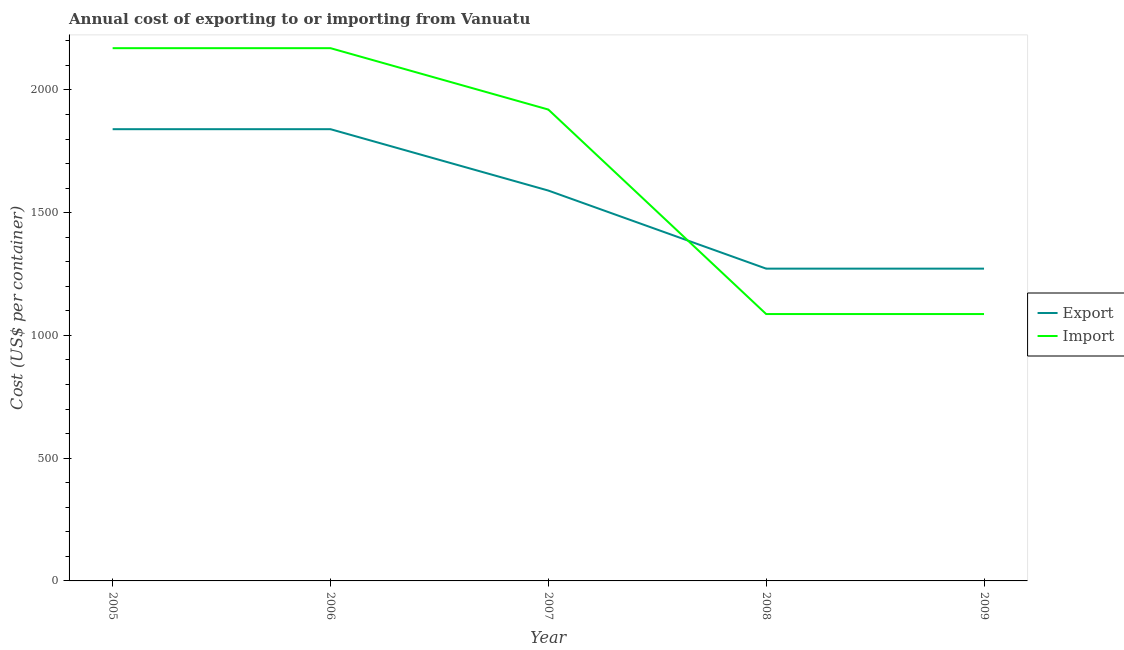Does the line corresponding to export cost intersect with the line corresponding to import cost?
Keep it short and to the point. Yes. Is the number of lines equal to the number of legend labels?
Give a very brief answer. Yes. What is the export cost in 2008?
Your response must be concise. 1272. Across all years, what is the maximum import cost?
Your response must be concise. 2170. Across all years, what is the minimum import cost?
Offer a terse response. 1087. In which year was the export cost minimum?
Give a very brief answer. 2008. What is the total export cost in the graph?
Your answer should be very brief. 7814. What is the difference between the export cost in 2005 and that in 2009?
Give a very brief answer. 568. What is the difference between the export cost in 2007 and the import cost in 2006?
Offer a very short reply. -580. What is the average export cost per year?
Make the answer very short. 1562.8. In the year 2009, what is the difference between the import cost and export cost?
Make the answer very short. -185. In how many years, is the import cost greater than 1000 US$?
Your response must be concise. 5. What is the ratio of the export cost in 2006 to that in 2008?
Offer a very short reply. 1.45. Is the export cost in 2007 less than that in 2009?
Your answer should be compact. No. Is the difference between the export cost in 2007 and 2009 greater than the difference between the import cost in 2007 and 2009?
Provide a succinct answer. No. What is the difference between the highest and the second highest export cost?
Your answer should be very brief. 0. What is the difference between the highest and the lowest export cost?
Offer a terse response. 568. In how many years, is the export cost greater than the average export cost taken over all years?
Provide a short and direct response. 3. Does the import cost monotonically increase over the years?
Ensure brevity in your answer.  No. Is the import cost strictly greater than the export cost over the years?
Your answer should be very brief. No. Is the export cost strictly less than the import cost over the years?
Your answer should be compact. No. How many years are there in the graph?
Offer a very short reply. 5. Does the graph contain any zero values?
Give a very brief answer. No. How are the legend labels stacked?
Your answer should be very brief. Vertical. What is the title of the graph?
Offer a terse response. Annual cost of exporting to or importing from Vanuatu. What is the label or title of the X-axis?
Make the answer very short. Year. What is the label or title of the Y-axis?
Give a very brief answer. Cost (US$ per container). What is the Cost (US$ per container) in Export in 2005?
Your answer should be compact. 1840. What is the Cost (US$ per container) of Import in 2005?
Give a very brief answer. 2170. What is the Cost (US$ per container) in Export in 2006?
Give a very brief answer. 1840. What is the Cost (US$ per container) in Import in 2006?
Provide a short and direct response. 2170. What is the Cost (US$ per container) in Export in 2007?
Offer a terse response. 1590. What is the Cost (US$ per container) of Import in 2007?
Ensure brevity in your answer.  1920. What is the Cost (US$ per container) of Export in 2008?
Make the answer very short. 1272. What is the Cost (US$ per container) of Import in 2008?
Your answer should be very brief. 1087. What is the Cost (US$ per container) in Export in 2009?
Your response must be concise. 1272. What is the Cost (US$ per container) in Import in 2009?
Keep it short and to the point. 1087. Across all years, what is the maximum Cost (US$ per container) in Export?
Provide a short and direct response. 1840. Across all years, what is the maximum Cost (US$ per container) of Import?
Your answer should be compact. 2170. Across all years, what is the minimum Cost (US$ per container) of Export?
Offer a terse response. 1272. Across all years, what is the minimum Cost (US$ per container) in Import?
Your answer should be very brief. 1087. What is the total Cost (US$ per container) of Export in the graph?
Give a very brief answer. 7814. What is the total Cost (US$ per container) in Import in the graph?
Give a very brief answer. 8434. What is the difference between the Cost (US$ per container) of Import in 2005 and that in 2006?
Your response must be concise. 0. What is the difference between the Cost (US$ per container) of Export in 2005 and that in 2007?
Ensure brevity in your answer.  250. What is the difference between the Cost (US$ per container) of Import in 2005 and that in 2007?
Provide a short and direct response. 250. What is the difference between the Cost (US$ per container) of Export in 2005 and that in 2008?
Provide a short and direct response. 568. What is the difference between the Cost (US$ per container) in Import in 2005 and that in 2008?
Provide a succinct answer. 1083. What is the difference between the Cost (US$ per container) of Export in 2005 and that in 2009?
Make the answer very short. 568. What is the difference between the Cost (US$ per container) in Import in 2005 and that in 2009?
Make the answer very short. 1083. What is the difference between the Cost (US$ per container) of Export in 2006 and that in 2007?
Your response must be concise. 250. What is the difference between the Cost (US$ per container) in Import in 2006 and that in 2007?
Your answer should be compact. 250. What is the difference between the Cost (US$ per container) of Export in 2006 and that in 2008?
Make the answer very short. 568. What is the difference between the Cost (US$ per container) in Import in 2006 and that in 2008?
Offer a very short reply. 1083. What is the difference between the Cost (US$ per container) in Export in 2006 and that in 2009?
Offer a terse response. 568. What is the difference between the Cost (US$ per container) in Import in 2006 and that in 2009?
Offer a very short reply. 1083. What is the difference between the Cost (US$ per container) in Export in 2007 and that in 2008?
Provide a succinct answer. 318. What is the difference between the Cost (US$ per container) of Import in 2007 and that in 2008?
Your answer should be very brief. 833. What is the difference between the Cost (US$ per container) in Export in 2007 and that in 2009?
Offer a terse response. 318. What is the difference between the Cost (US$ per container) of Import in 2007 and that in 2009?
Offer a very short reply. 833. What is the difference between the Cost (US$ per container) in Export in 2008 and that in 2009?
Provide a short and direct response. 0. What is the difference between the Cost (US$ per container) in Export in 2005 and the Cost (US$ per container) in Import in 2006?
Provide a succinct answer. -330. What is the difference between the Cost (US$ per container) in Export in 2005 and the Cost (US$ per container) in Import in 2007?
Your answer should be compact. -80. What is the difference between the Cost (US$ per container) in Export in 2005 and the Cost (US$ per container) in Import in 2008?
Give a very brief answer. 753. What is the difference between the Cost (US$ per container) of Export in 2005 and the Cost (US$ per container) of Import in 2009?
Offer a very short reply. 753. What is the difference between the Cost (US$ per container) of Export in 2006 and the Cost (US$ per container) of Import in 2007?
Provide a succinct answer. -80. What is the difference between the Cost (US$ per container) in Export in 2006 and the Cost (US$ per container) in Import in 2008?
Your answer should be compact. 753. What is the difference between the Cost (US$ per container) of Export in 2006 and the Cost (US$ per container) of Import in 2009?
Your answer should be compact. 753. What is the difference between the Cost (US$ per container) of Export in 2007 and the Cost (US$ per container) of Import in 2008?
Ensure brevity in your answer.  503. What is the difference between the Cost (US$ per container) of Export in 2007 and the Cost (US$ per container) of Import in 2009?
Your response must be concise. 503. What is the difference between the Cost (US$ per container) of Export in 2008 and the Cost (US$ per container) of Import in 2009?
Provide a succinct answer. 185. What is the average Cost (US$ per container) in Export per year?
Ensure brevity in your answer.  1562.8. What is the average Cost (US$ per container) in Import per year?
Ensure brevity in your answer.  1686.8. In the year 2005, what is the difference between the Cost (US$ per container) of Export and Cost (US$ per container) of Import?
Give a very brief answer. -330. In the year 2006, what is the difference between the Cost (US$ per container) in Export and Cost (US$ per container) in Import?
Offer a very short reply. -330. In the year 2007, what is the difference between the Cost (US$ per container) of Export and Cost (US$ per container) of Import?
Your response must be concise. -330. In the year 2008, what is the difference between the Cost (US$ per container) of Export and Cost (US$ per container) of Import?
Your answer should be compact. 185. In the year 2009, what is the difference between the Cost (US$ per container) of Export and Cost (US$ per container) of Import?
Provide a succinct answer. 185. What is the ratio of the Cost (US$ per container) in Export in 2005 to that in 2006?
Keep it short and to the point. 1. What is the ratio of the Cost (US$ per container) in Export in 2005 to that in 2007?
Your response must be concise. 1.16. What is the ratio of the Cost (US$ per container) in Import in 2005 to that in 2007?
Ensure brevity in your answer.  1.13. What is the ratio of the Cost (US$ per container) of Export in 2005 to that in 2008?
Keep it short and to the point. 1.45. What is the ratio of the Cost (US$ per container) of Import in 2005 to that in 2008?
Provide a succinct answer. 2. What is the ratio of the Cost (US$ per container) in Export in 2005 to that in 2009?
Give a very brief answer. 1.45. What is the ratio of the Cost (US$ per container) in Import in 2005 to that in 2009?
Your answer should be compact. 2. What is the ratio of the Cost (US$ per container) in Export in 2006 to that in 2007?
Provide a short and direct response. 1.16. What is the ratio of the Cost (US$ per container) of Import in 2006 to that in 2007?
Your answer should be compact. 1.13. What is the ratio of the Cost (US$ per container) in Export in 2006 to that in 2008?
Your answer should be compact. 1.45. What is the ratio of the Cost (US$ per container) in Import in 2006 to that in 2008?
Ensure brevity in your answer.  2. What is the ratio of the Cost (US$ per container) in Export in 2006 to that in 2009?
Keep it short and to the point. 1.45. What is the ratio of the Cost (US$ per container) of Import in 2006 to that in 2009?
Offer a very short reply. 2. What is the ratio of the Cost (US$ per container) in Import in 2007 to that in 2008?
Make the answer very short. 1.77. What is the ratio of the Cost (US$ per container) in Export in 2007 to that in 2009?
Ensure brevity in your answer.  1.25. What is the ratio of the Cost (US$ per container) in Import in 2007 to that in 2009?
Your answer should be compact. 1.77. What is the ratio of the Cost (US$ per container) of Export in 2008 to that in 2009?
Keep it short and to the point. 1. What is the ratio of the Cost (US$ per container) in Import in 2008 to that in 2009?
Give a very brief answer. 1. What is the difference between the highest and the second highest Cost (US$ per container) in Import?
Make the answer very short. 0. What is the difference between the highest and the lowest Cost (US$ per container) of Export?
Provide a succinct answer. 568. What is the difference between the highest and the lowest Cost (US$ per container) in Import?
Your answer should be very brief. 1083. 